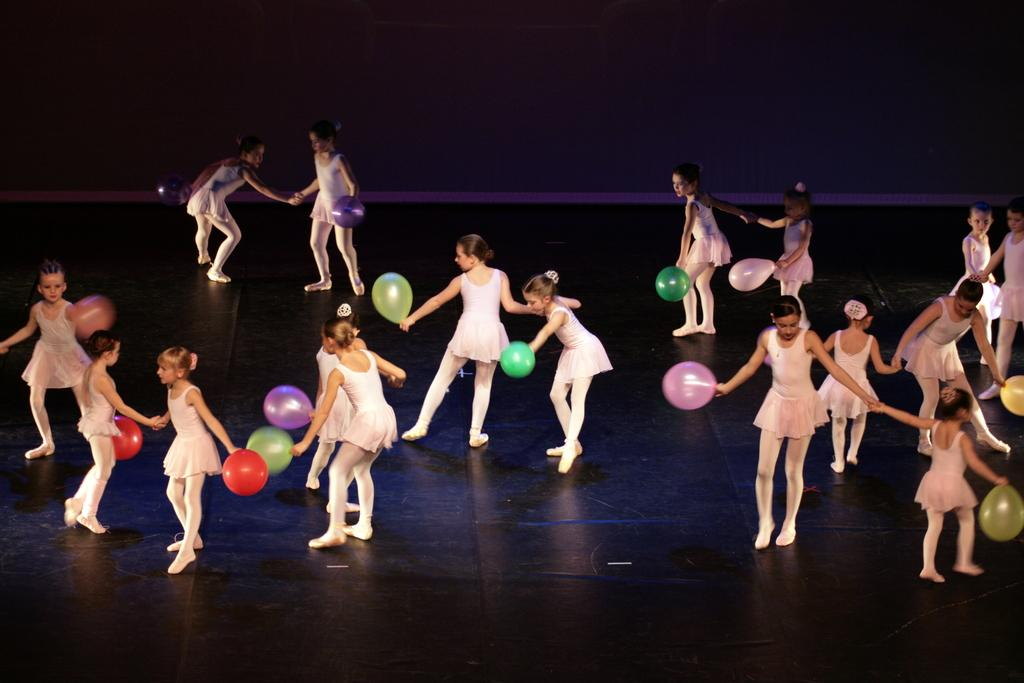What are the people in the image doing? The people in the image are dancing on the floor. What are the people holding while dancing? The people are holding balloons. What can be said about the appearance of the balloons? The balloons are in different colors. What can be seen in the background of the image? There is a wall visible in the background of the image. How many toes can be seen on the people dancing in the image? It is not possible to determine the number of toes visible in the image, as the focus is on the people dancing and holding balloons, not their feet. 